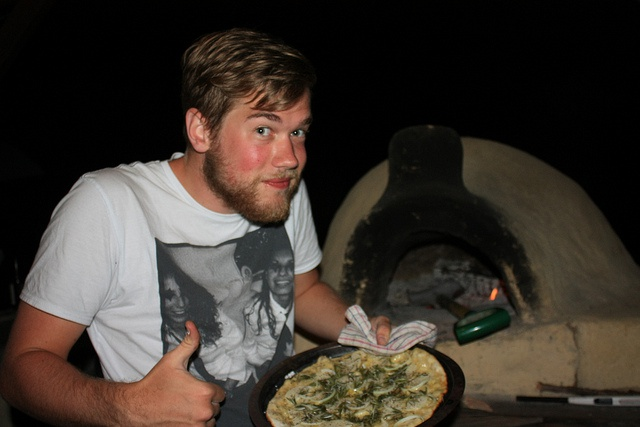Describe the objects in this image and their specific colors. I can see people in black, darkgray, brown, and maroon tones and pizza in black, olive, and gray tones in this image. 